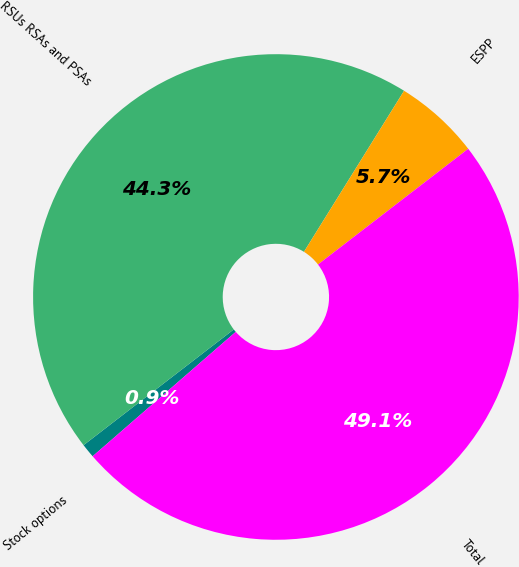Convert chart to OTSL. <chart><loc_0><loc_0><loc_500><loc_500><pie_chart><fcel>Stock options<fcel>RSUs RSAs and PSAs<fcel>ESPP<fcel>Total<nl><fcel>0.94%<fcel>44.3%<fcel>5.7%<fcel>49.06%<nl></chart> 